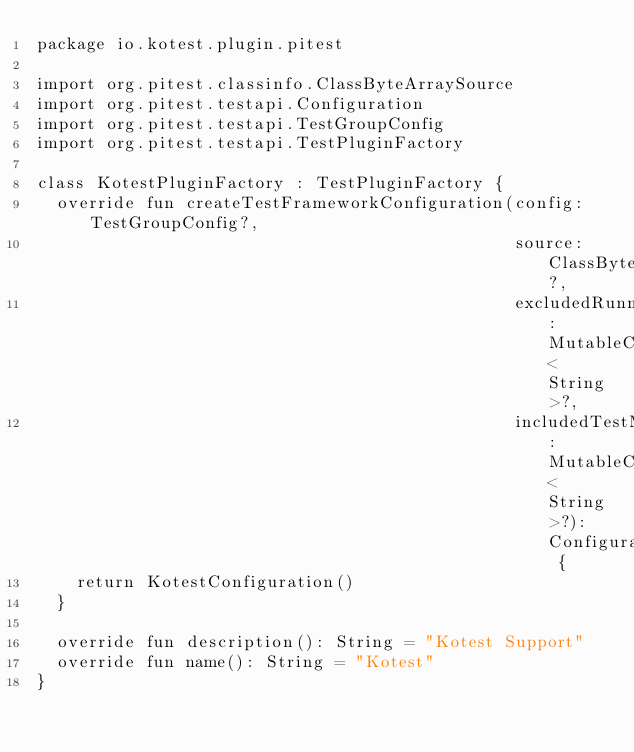<code> <loc_0><loc_0><loc_500><loc_500><_Kotlin_>package io.kotest.plugin.pitest

import org.pitest.classinfo.ClassByteArraySource
import org.pitest.testapi.Configuration
import org.pitest.testapi.TestGroupConfig
import org.pitest.testapi.TestPluginFactory

class KotestPluginFactory : TestPluginFactory {
  override fun createTestFrameworkConfiguration(config: TestGroupConfig?,
                                                source: ClassByteArraySource?,
                                                excludedRunners: MutableCollection<String>?,
                                                includedTestMethods: MutableCollection<String>?): Configuration {
    return KotestConfiguration()
  }

  override fun description(): String = "Kotest Support"
  override fun name(): String = "Kotest"
}</code> 